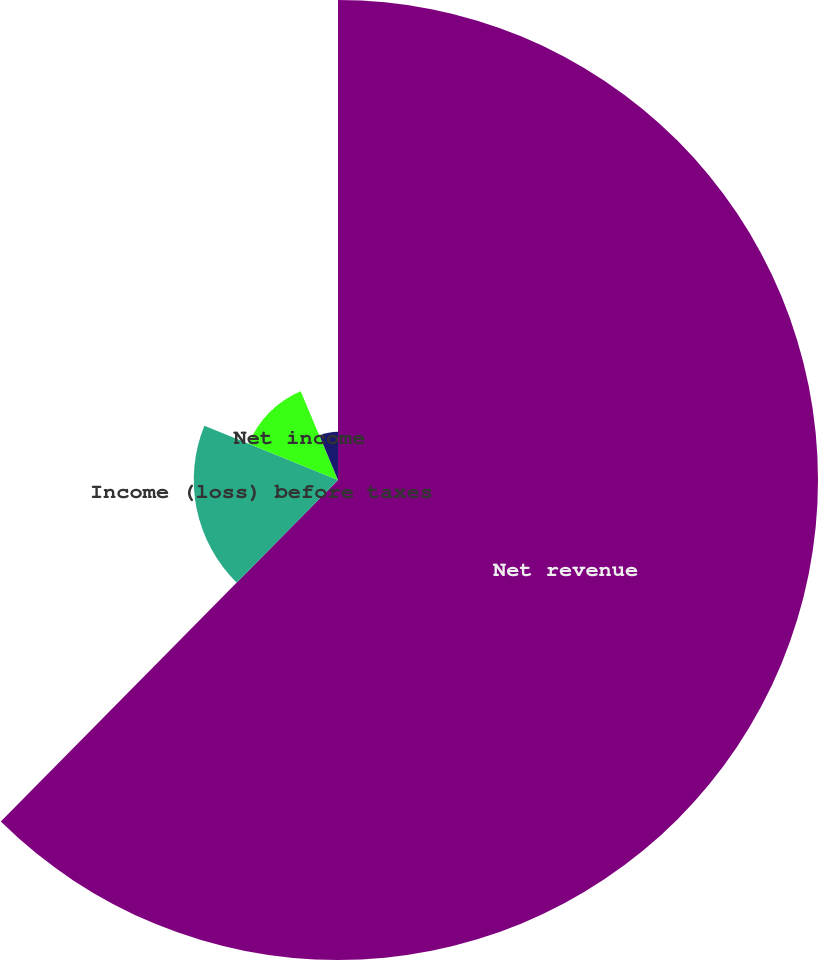Convert chart to OTSL. <chart><loc_0><loc_0><loc_500><loc_500><pie_chart><fcel>Net revenue<fcel>Income (loss) before taxes<fcel>Net income<fcel>Basic<fcel>Diluted<nl><fcel>62.39%<fcel>18.75%<fcel>12.52%<fcel>0.05%<fcel>6.28%<nl></chart> 